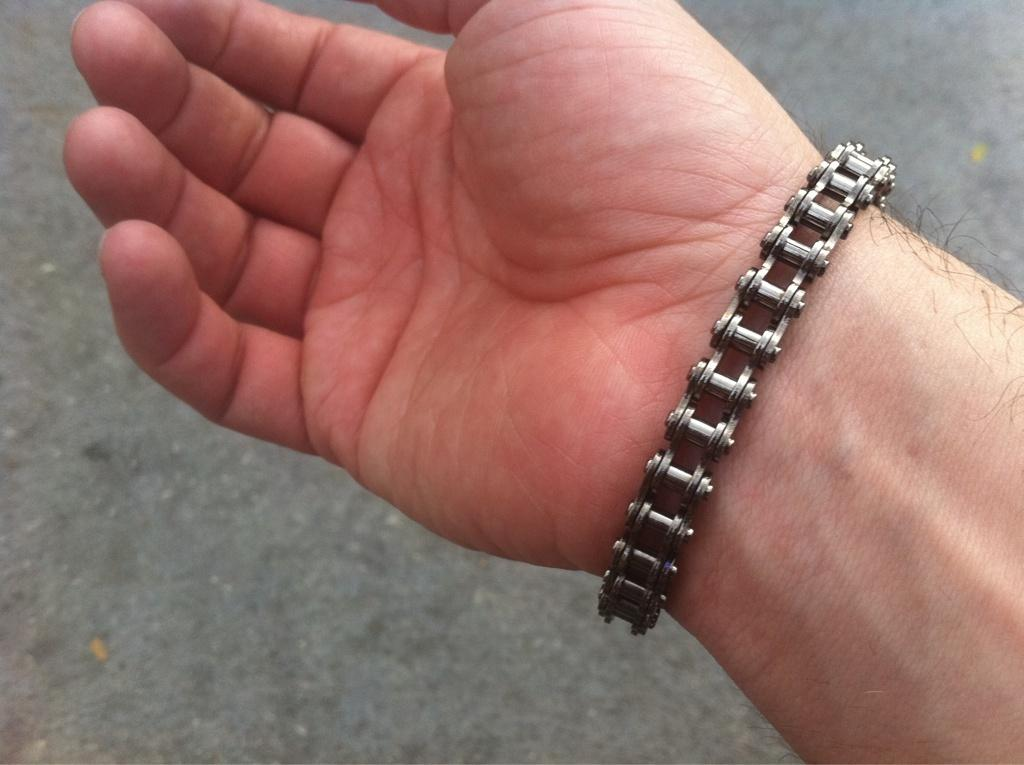What part of a person can be seen in the image? There is a person's hand in the image. What is the person wearing on their hand? The person is wearing a bracelet. What type of surface is visible in the background of the image? There is a rough surface in the background of the image. Can you see any wings in the image? There are no wings present in the image. What type of blade is visible in the image? There is no blade present in the image. 